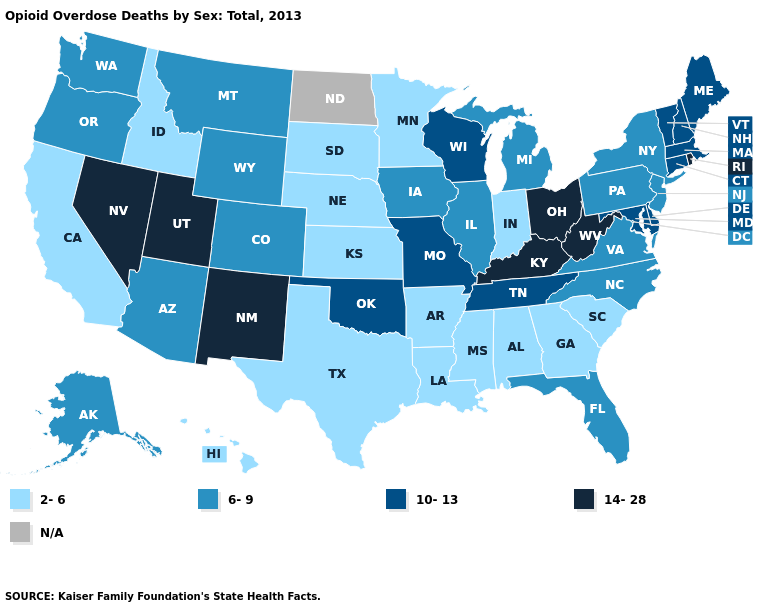Name the states that have a value in the range 14-28?
Concise answer only. Kentucky, Nevada, New Mexico, Ohio, Rhode Island, Utah, West Virginia. Among the states that border Idaho , does Nevada have the highest value?
Short answer required. Yes. Name the states that have a value in the range N/A?
Concise answer only. North Dakota. Is the legend a continuous bar?
Be succinct. No. Among the states that border Idaho , does Wyoming have the highest value?
Keep it brief. No. Among the states that border Oklahoma , does Missouri have the highest value?
Give a very brief answer. No. Which states have the highest value in the USA?
Concise answer only. Kentucky, Nevada, New Mexico, Ohio, Rhode Island, Utah, West Virginia. What is the value of Rhode Island?
Write a very short answer. 14-28. Among the states that border Ohio , which have the lowest value?
Answer briefly. Indiana. Does New Mexico have the highest value in the West?
Write a very short answer. Yes. What is the highest value in the USA?
Short answer required. 14-28. Name the states that have a value in the range N/A?
Write a very short answer. North Dakota. Does Kentucky have the highest value in the USA?
Short answer required. Yes. Does Iowa have the lowest value in the USA?
Short answer required. No. 